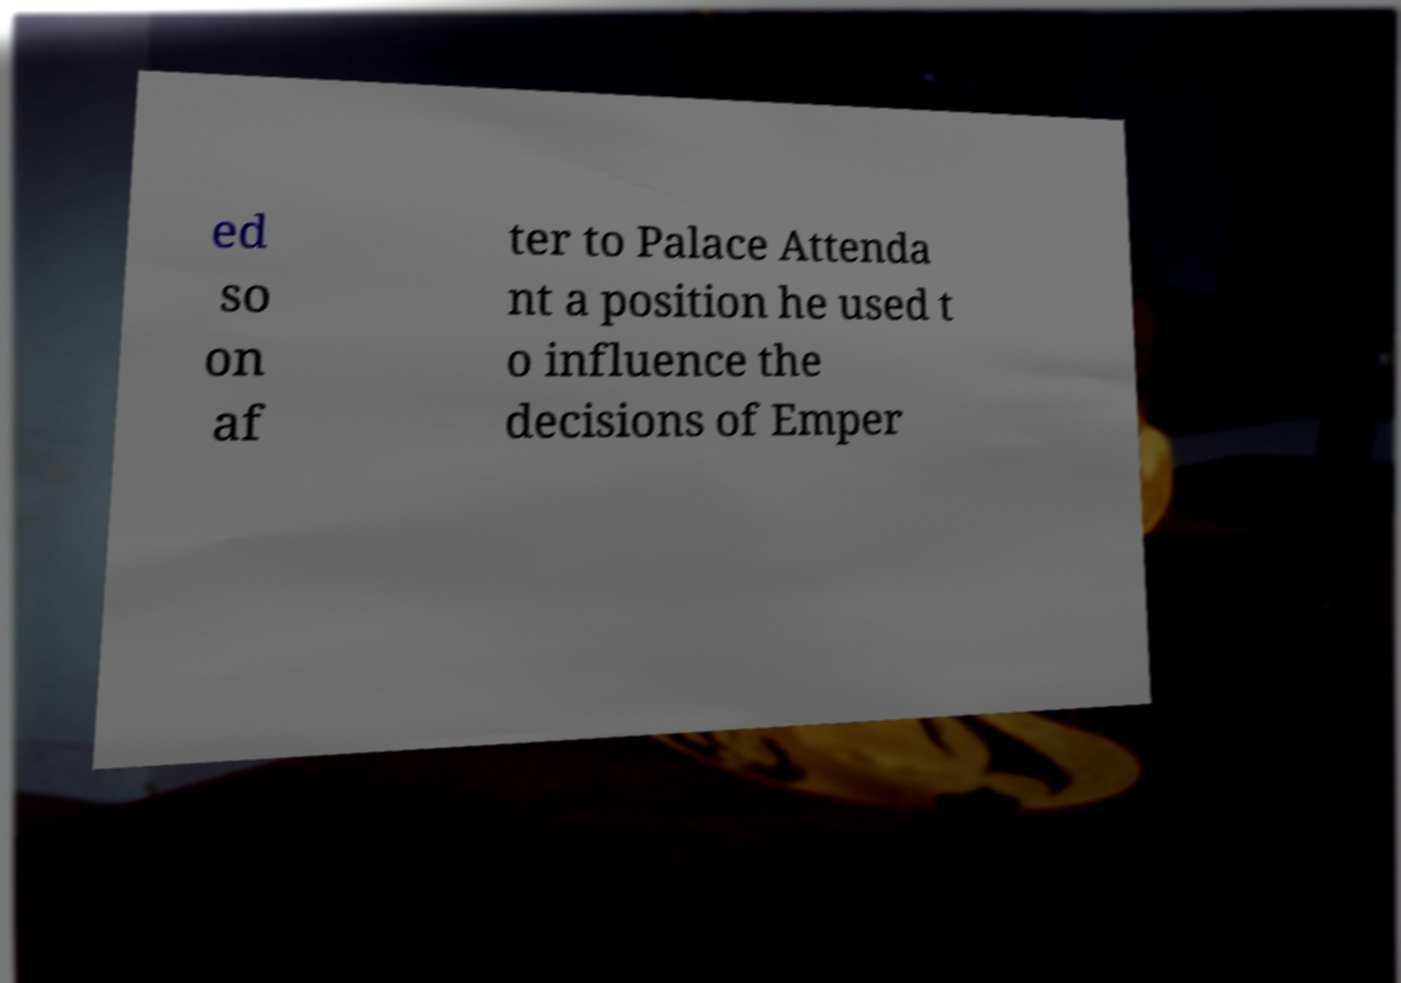Could you assist in decoding the text presented in this image and type it out clearly? ed so on af ter to Palace Attenda nt a position he used t o influence the decisions of Emper 